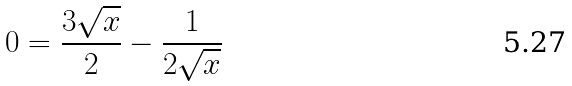Convert formula to latex. <formula><loc_0><loc_0><loc_500><loc_500>0 = \frac { 3 \sqrt { x } } { 2 } - \frac { 1 } { 2 \sqrt { x } }</formula> 